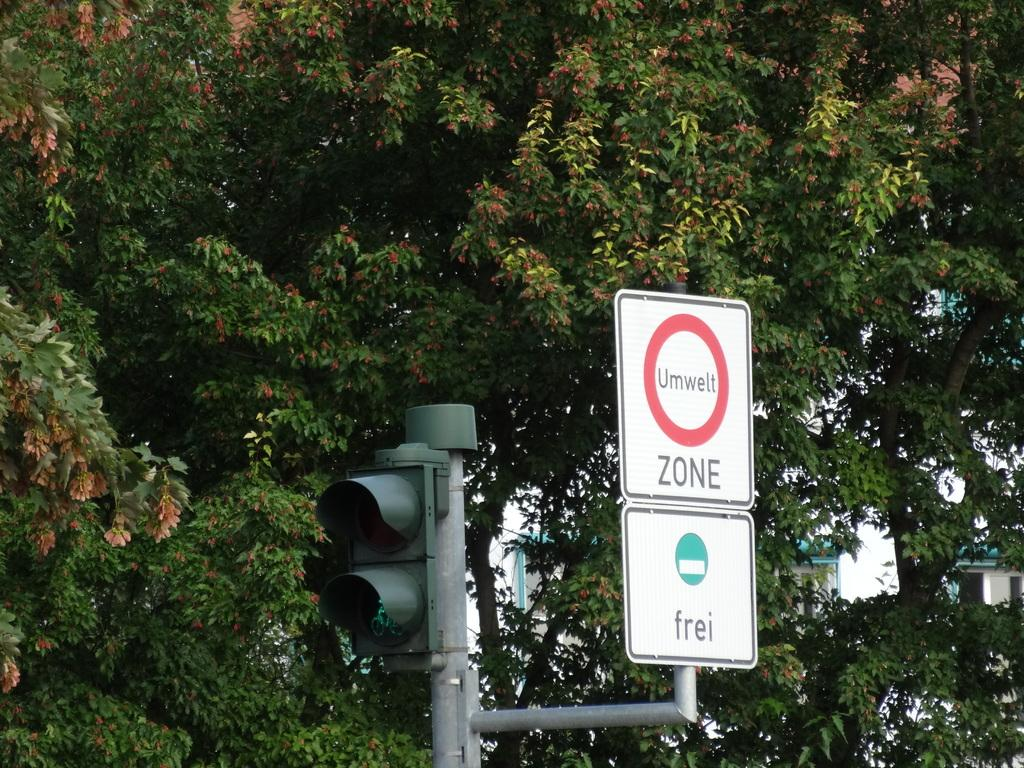<image>
Render a clear and concise summary of the photo. A sign reading Zone in front of some trees. 